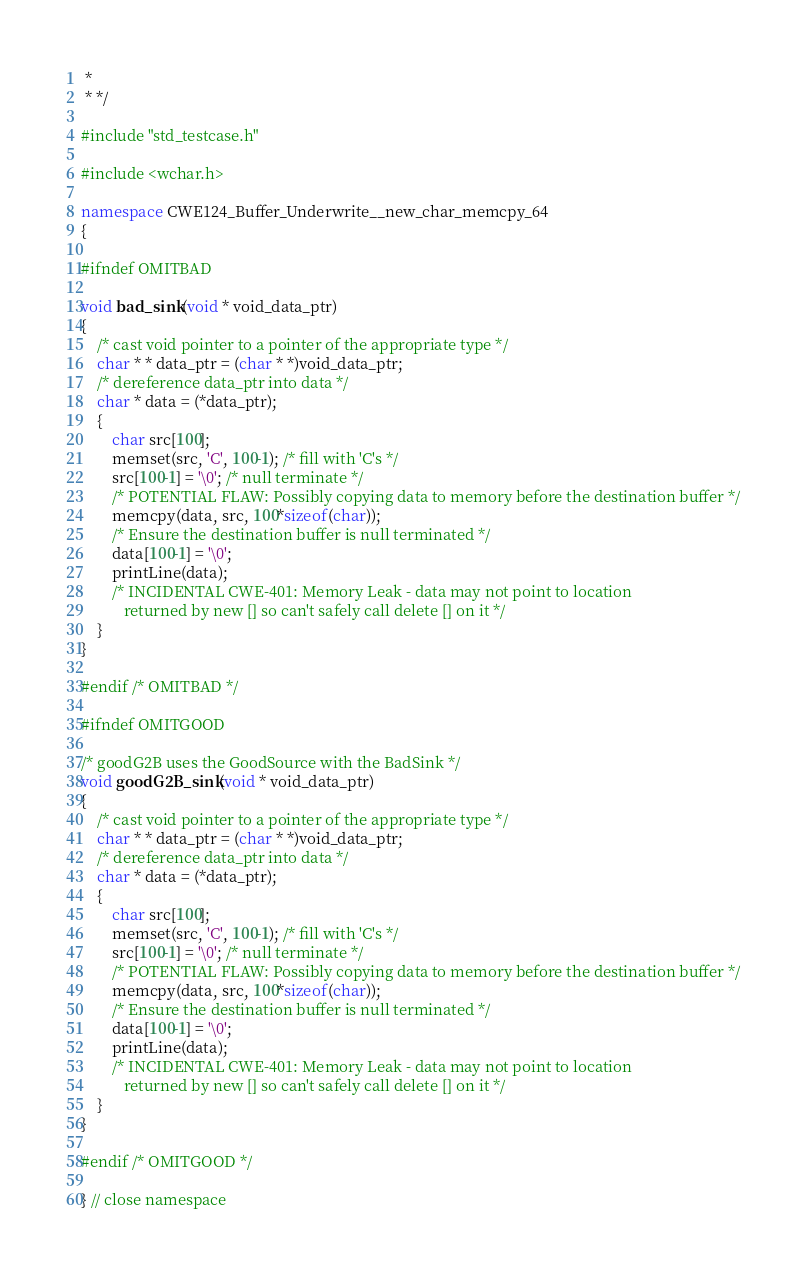Convert code to text. <code><loc_0><loc_0><loc_500><loc_500><_C++_> *
 * */

#include "std_testcase.h"

#include <wchar.h>

namespace CWE124_Buffer_Underwrite__new_char_memcpy_64
{

#ifndef OMITBAD

void bad_sink(void * void_data_ptr)
{
    /* cast void pointer to a pointer of the appropriate type */
    char * * data_ptr = (char * *)void_data_ptr;
    /* dereference data_ptr into data */
    char * data = (*data_ptr);
    {
        char src[100];
        memset(src, 'C', 100-1); /* fill with 'C's */
        src[100-1] = '\0'; /* null terminate */
        /* POTENTIAL FLAW: Possibly copying data to memory before the destination buffer */
        memcpy(data, src, 100*sizeof(char));
        /* Ensure the destination buffer is null terminated */
        data[100-1] = '\0';
        printLine(data);
        /* INCIDENTAL CWE-401: Memory Leak - data may not point to location
           returned by new [] so can't safely call delete [] on it */
    }
}

#endif /* OMITBAD */

#ifndef OMITGOOD

/* goodG2B uses the GoodSource with the BadSink */
void goodG2B_sink(void * void_data_ptr)
{
    /* cast void pointer to a pointer of the appropriate type */
    char * * data_ptr = (char * *)void_data_ptr;
    /* dereference data_ptr into data */
    char * data = (*data_ptr);
    {
        char src[100];
        memset(src, 'C', 100-1); /* fill with 'C's */
        src[100-1] = '\0'; /* null terminate */
        /* POTENTIAL FLAW: Possibly copying data to memory before the destination buffer */
        memcpy(data, src, 100*sizeof(char));
        /* Ensure the destination buffer is null terminated */
        data[100-1] = '\0';
        printLine(data);
        /* INCIDENTAL CWE-401: Memory Leak - data may not point to location
           returned by new [] so can't safely call delete [] on it */
    }
}

#endif /* OMITGOOD */

} // close namespace
</code> 